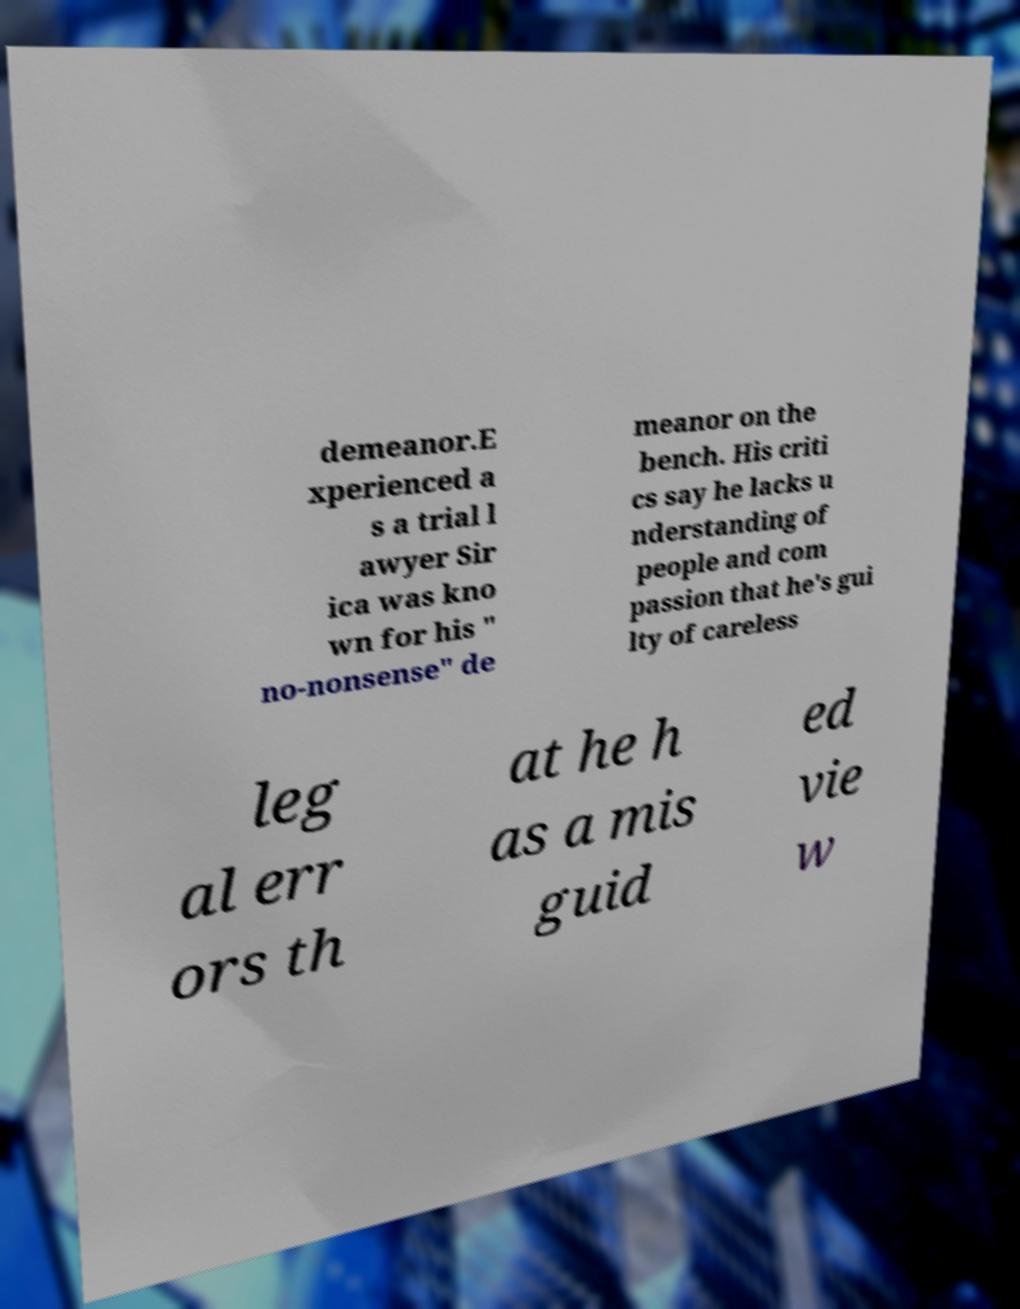For documentation purposes, I need the text within this image transcribed. Could you provide that? demeanor.E xperienced a s a trial l awyer Sir ica was kno wn for his " no-nonsense" de meanor on the bench. His criti cs say he lacks u nderstanding of people and com passion that he's gui lty of careless leg al err ors th at he h as a mis guid ed vie w 